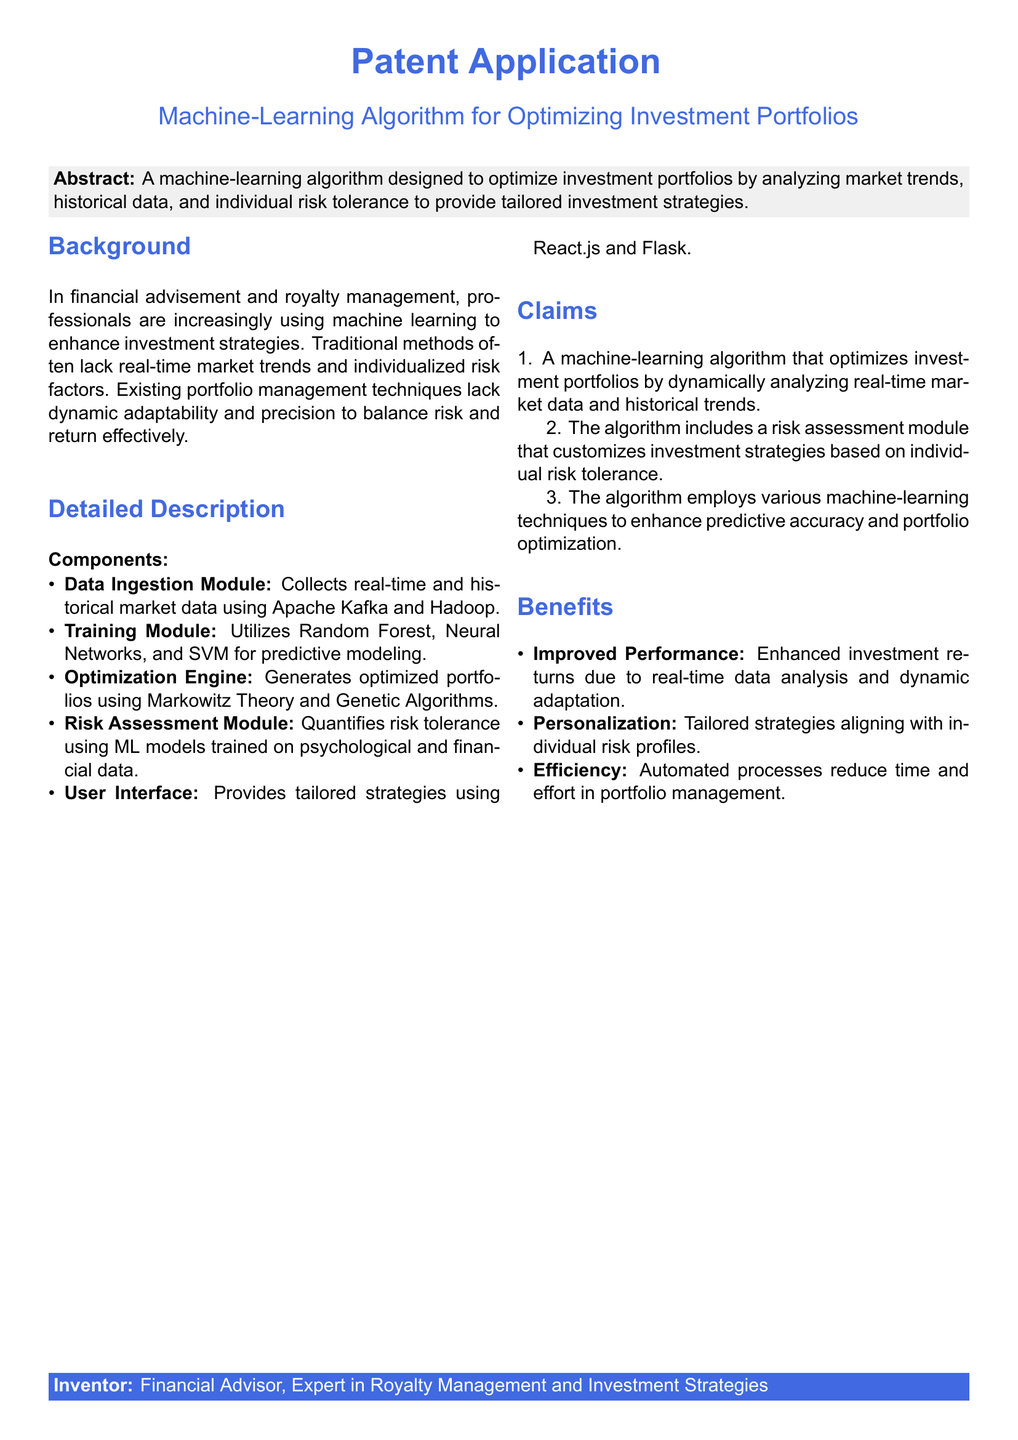What is the title of the patent application? The title is found in the centered section at the top of the document.
Answer: Machine-Learning Algorithm for Optimizing Investment Portfolios What are the components of the algorithm? The components are listed in the Detailed Description section, including a Data Ingestion Module and Training Module.
Answer: Data Ingestion Module, Training Module, Optimization Engine, Risk Assessment Module, User Interface Who is the inventor mentioned in the document? This information is typically found at the bottom in a highlighted box.
Answer: Financial Advisor, Expert in Royalty Management and Investment Strategies What is one technique used for predictive modeling in the training module? The techniques for predictive modeling are mentioned in the Detailed Description.
Answer: Random Forest What is the primary benefit of the machine-learning algorithm? This benefit is highlighted in the Benefits section of the document.
Answer: Improved Performance How does the risk assessment module customize strategies? This is explained in the Claims section among the algorithm's features.
Answer: Based on individual risk tolerance What method does the optimization engine use? The method is specified in the Detailed Description section of the algorithm.
Answer: Markowitz Theory and Genetic Algorithms What type of data does the Data Ingestion Module collect? The type of data is documented under the component descriptions in the Document.
Answer: Real-time and historical market data 